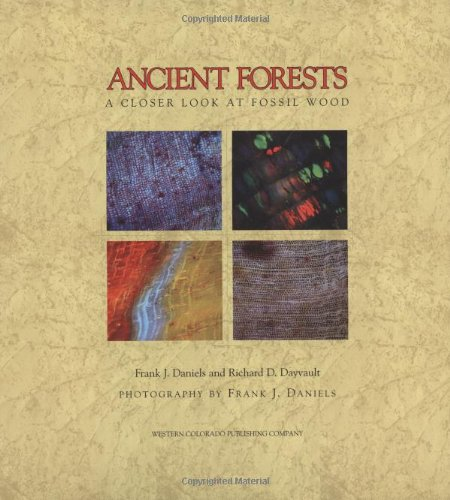Is this book related to Comics & Graphic Novels? No, this book is not related to Comics & Graphic Novels. It is a scientific exploration focused on fossil woods, utilizing photography and detailed textual analysis to discuss its subjects. 